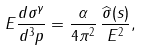<formula> <loc_0><loc_0><loc_500><loc_500>E \frac { d \sigma ^ { \gamma } } { d ^ { 3 } p } = \frac { \alpha } { 4 \pi ^ { 2 } } \, \frac { \widehat { \sigma } ( s ) } { E ^ { 2 } } ,</formula> 